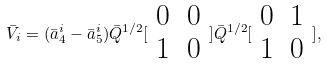Convert formula to latex. <formula><loc_0><loc_0><loc_500><loc_500>\bar { V } _ { i } = ( \bar { a } _ { 4 } ^ { i } - \bar { a } _ { 5 } ^ { i } ) \bar { Q } ^ { 1 / 2 } [ \begin{array} { c c } 0 & 0 \\ 1 & 0 \end{array} ] \bar { Q } ^ { 1 / 2 } [ \begin{array} { c c } 0 & 1 \\ 1 & 0 \end{array} ] ,</formula> 